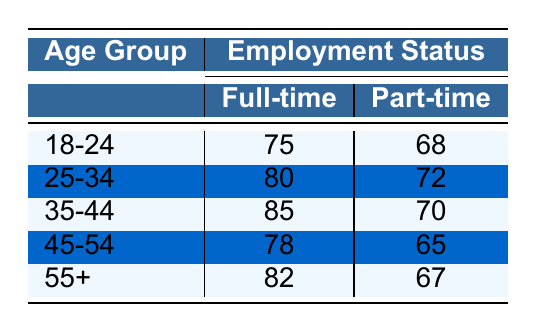What is the satisfaction score for full-time employees aged 25-34? The table shows that for full-time employees in the age group 25-34, the satisfaction score is 80.
Answer: 80 What is the difference in satisfaction scores between part-time employees aged 35-44 and aged 45-54? The satisfaction score for part-time employees aged 35-44 is 70, and for those aged 45-54, it is 65. The difference is 70 - 65 = 5.
Answer: 5 Is the satisfaction score for full-time employees in the age group 55+ higher than that of part-time employees in the same age group? The satisfaction score for full-time employees aged 55+ is 82, while the score for part-time employees in the same age group is 67. Since 82 is greater than 67, the statement is true.
Answer: Yes What is the average satisfaction score of part-time employees across all age groups? The satisfaction scores for part-time employees by age group are 68, 72, 70, 65, and 67. To find the average, we sum these scores: 68 + 72 + 70 + 65 + 67 = 342, and divide by 5, resulting in an average of 342/5 = 68.4.
Answer: 68.4 Which age group has the highest satisfaction score among full-time employees? The scores for full-time employees are 75 (18-24), 80 (25-34), 85 (35-44), 78 (45-54), and 82 (55+). The highest score is 85, which belongs to the age group 35-44.
Answer: 35-44 